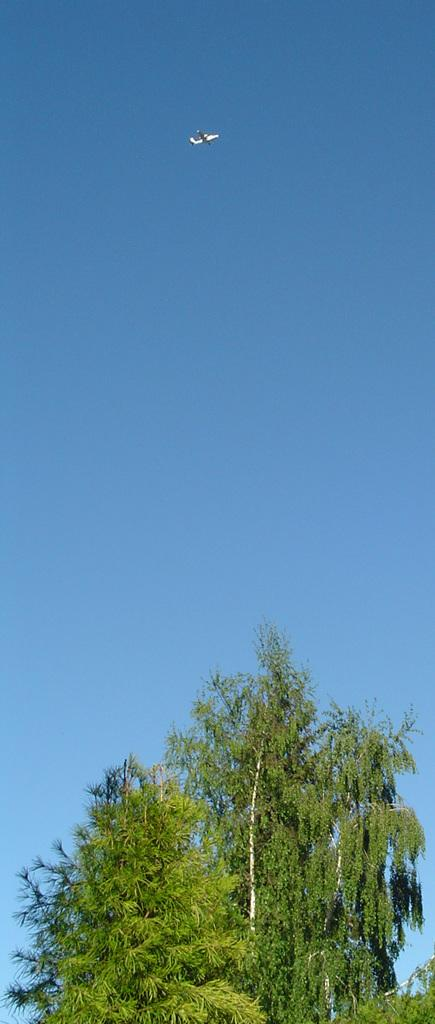What type of vegetation can be seen in the image? There are trees in the image. What is flying in the sky in the image? There is an airplane in the air in the image. What can be seen in the background of the image? The sky is visible in the background of the image. What type of cabbage is growing on the moon in the image? There is no cabbage or moon present in the image; it features trees and an airplane in the sky. 